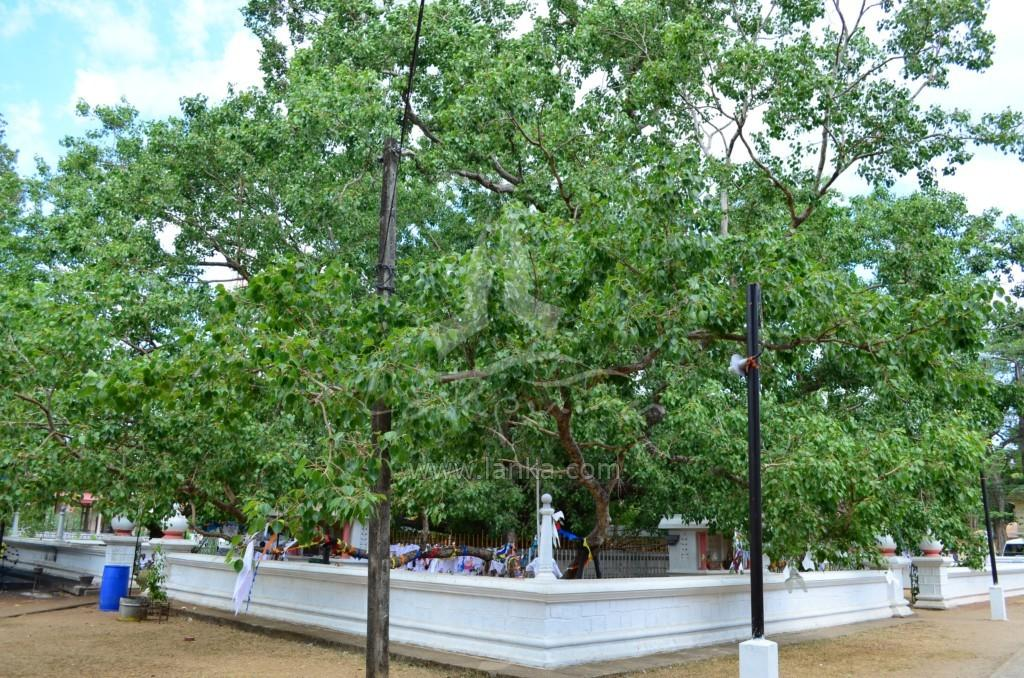What type of vegetation can be seen in the image? There is a group of trees in the image. What architectural feature is present in the image? There is a wall with pillars in the image. What objects are present in the image that might be used for support or structure? There are poles in the image. What musical instrument can be seen in the image? There is a drum in the image. What type of container with a plant is visible in the image? There is a pot with a plant in the image. What is the condition of the sky in the image? The sky is visible in the image and appears cloudy. What type of wool is being used to make a sweater for the son in the image? There is no son or sweater present in the image; it features a group of trees, a wall with pillars, poles, a drum, a pot with a plant, and a cloudy sky. What type of hospital can be seen in the background of the image? There is no hospital present in the image; it features a group of trees, a wall with pillars, poles, a drum, a pot with a plant, and a cloudy sky. 